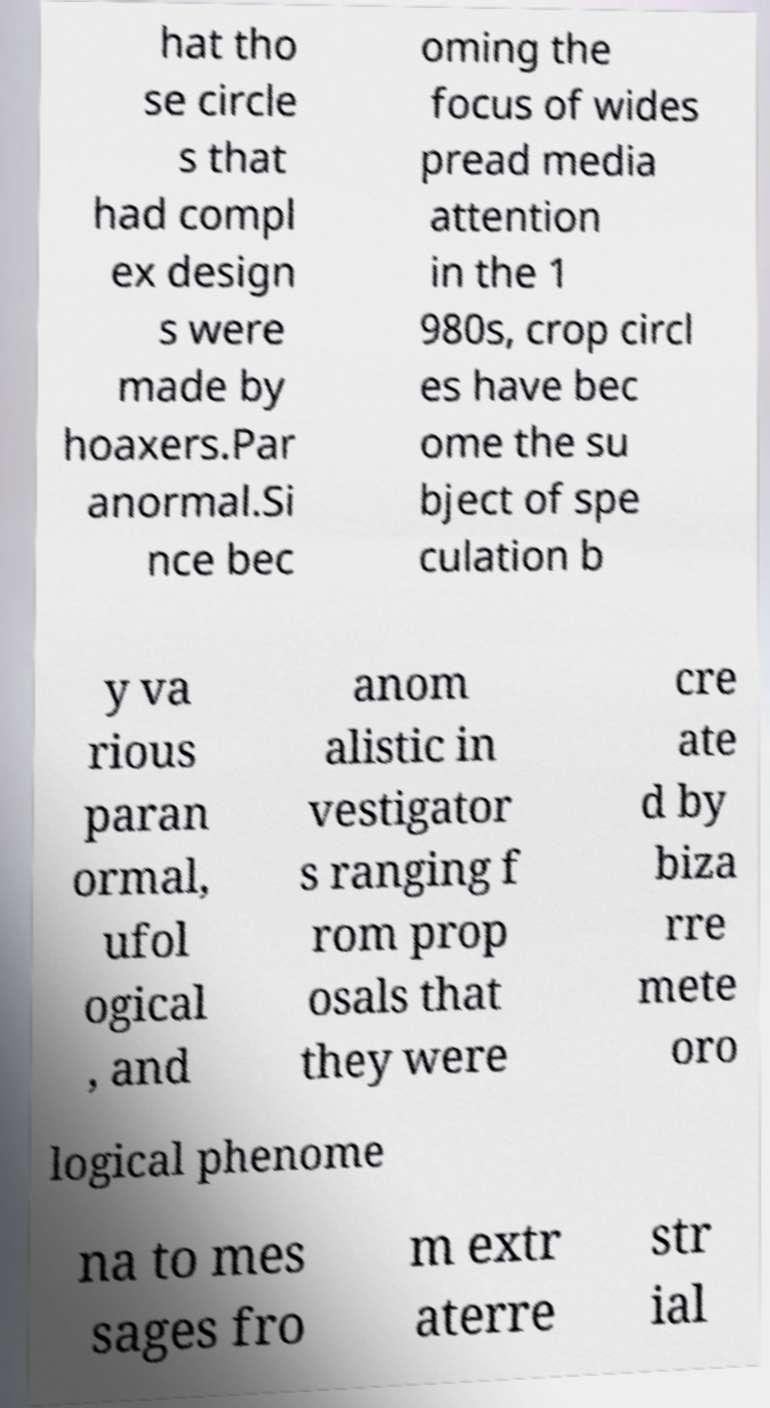Can you accurately transcribe the text from the provided image for me? hat tho se circle s that had compl ex design s were made by hoaxers.Par anormal.Si nce bec oming the focus of wides pread media attention in the 1 980s, crop circl es have bec ome the su bject of spe culation b y va rious paran ormal, ufol ogical , and anom alistic in vestigator s ranging f rom prop osals that they were cre ate d by biza rre mete oro logical phenome na to mes sages fro m extr aterre str ial 